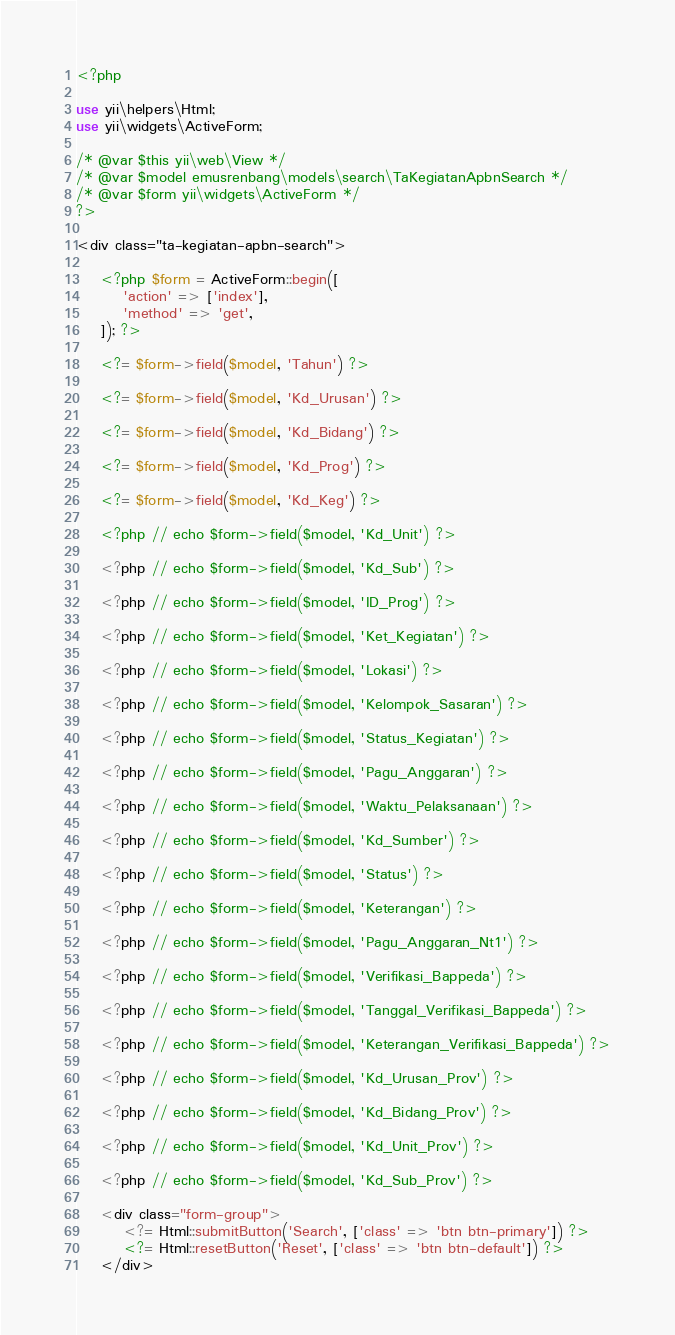Convert code to text. <code><loc_0><loc_0><loc_500><loc_500><_PHP_><?php

use yii\helpers\Html;
use yii\widgets\ActiveForm;

/* @var $this yii\web\View */
/* @var $model emusrenbang\models\search\TaKegiatanApbnSearch */
/* @var $form yii\widgets\ActiveForm */
?>

<div class="ta-kegiatan-apbn-search">

    <?php $form = ActiveForm::begin([
        'action' => ['index'],
        'method' => 'get',
    ]); ?>

    <?= $form->field($model, 'Tahun') ?>

    <?= $form->field($model, 'Kd_Urusan') ?>

    <?= $form->field($model, 'Kd_Bidang') ?>

    <?= $form->field($model, 'Kd_Prog') ?>

    <?= $form->field($model, 'Kd_Keg') ?>

    <?php // echo $form->field($model, 'Kd_Unit') ?>

    <?php // echo $form->field($model, 'Kd_Sub') ?>

    <?php // echo $form->field($model, 'ID_Prog') ?>

    <?php // echo $form->field($model, 'Ket_Kegiatan') ?>

    <?php // echo $form->field($model, 'Lokasi') ?>

    <?php // echo $form->field($model, 'Kelompok_Sasaran') ?>

    <?php // echo $form->field($model, 'Status_Kegiatan') ?>

    <?php // echo $form->field($model, 'Pagu_Anggaran') ?>

    <?php // echo $form->field($model, 'Waktu_Pelaksanaan') ?>

    <?php // echo $form->field($model, 'Kd_Sumber') ?>

    <?php // echo $form->field($model, 'Status') ?>

    <?php // echo $form->field($model, 'Keterangan') ?>

    <?php // echo $form->field($model, 'Pagu_Anggaran_Nt1') ?>

    <?php // echo $form->field($model, 'Verifikasi_Bappeda') ?>

    <?php // echo $form->field($model, 'Tanggal_Verifikasi_Bappeda') ?>

    <?php // echo $form->field($model, 'Keterangan_Verifikasi_Bappeda') ?>

    <?php // echo $form->field($model, 'Kd_Urusan_Prov') ?>

    <?php // echo $form->field($model, 'Kd_Bidang_Prov') ?>

    <?php // echo $form->field($model, 'Kd_Unit_Prov') ?>

    <?php // echo $form->field($model, 'Kd_Sub_Prov') ?>

    <div class="form-group">
        <?= Html::submitButton('Search', ['class' => 'btn btn-primary']) ?>
        <?= Html::resetButton('Reset', ['class' => 'btn btn-default']) ?>
    </div>
</code> 